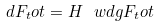Convert formula to latex. <formula><loc_0><loc_0><loc_500><loc_500>d F _ { t } o t = H \ w d g F _ { t } o t</formula> 